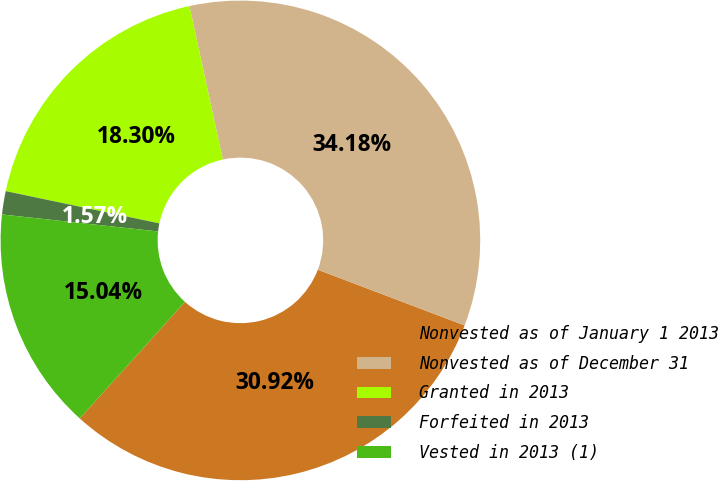Convert chart to OTSL. <chart><loc_0><loc_0><loc_500><loc_500><pie_chart><fcel>Nonvested as of January 1 2013<fcel>Nonvested as of December 31<fcel>Granted in 2013<fcel>Forfeited in 2013<fcel>Vested in 2013 (1)<nl><fcel>30.92%<fcel>34.18%<fcel>18.3%<fcel>1.57%<fcel>15.04%<nl></chart> 